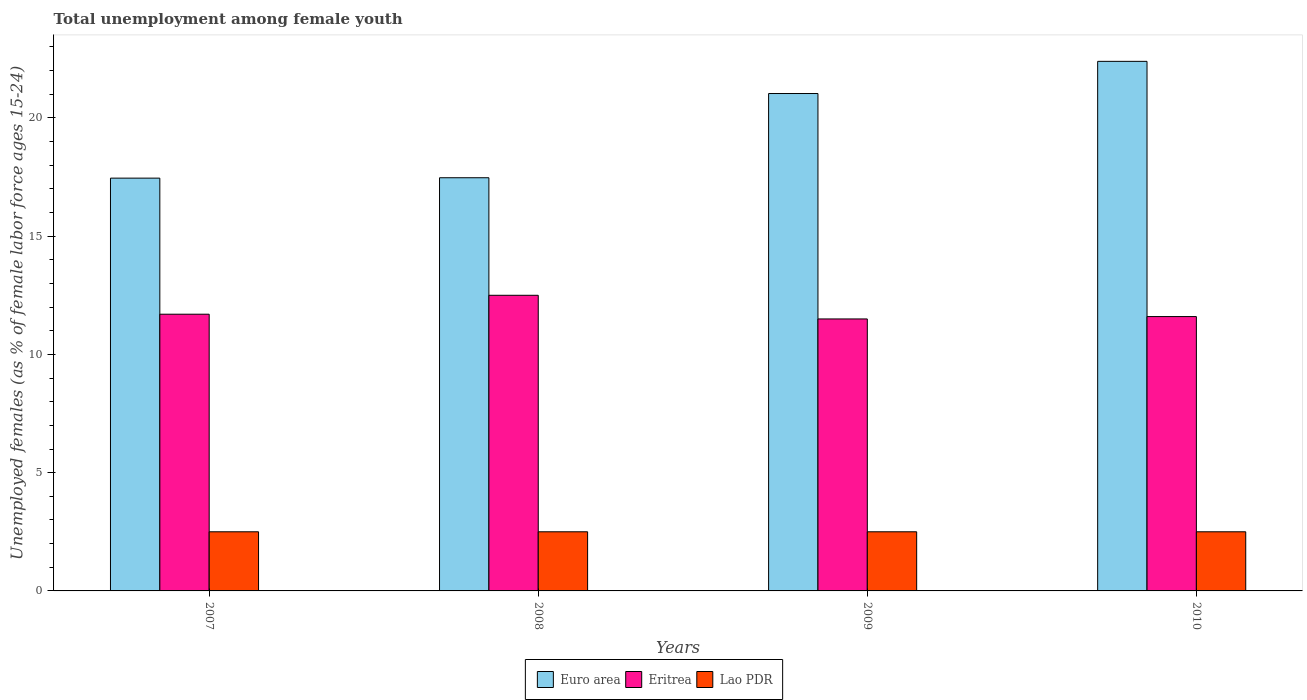How many different coloured bars are there?
Keep it short and to the point. 3. How many groups of bars are there?
Ensure brevity in your answer.  4. How many bars are there on the 3rd tick from the left?
Your response must be concise. 3. What is the label of the 4th group of bars from the left?
Keep it short and to the point. 2010. In how many cases, is the number of bars for a given year not equal to the number of legend labels?
Ensure brevity in your answer.  0. What is the percentage of unemployed females in in Euro area in 2007?
Give a very brief answer. 17.45. Across all years, what is the maximum percentage of unemployed females in in Euro area?
Provide a succinct answer. 22.39. In which year was the percentage of unemployed females in in Lao PDR minimum?
Your answer should be very brief. 2007. What is the total percentage of unemployed females in in Lao PDR in the graph?
Provide a succinct answer. 10. What is the difference between the percentage of unemployed females in in Euro area in 2007 and that in 2010?
Keep it short and to the point. -4.94. What is the difference between the percentage of unemployed females in in Euro area in 2010 and the percentage of unemployed females in in Eritrea in 2009?
Offer a very short reply. 10.89. In the year 2009, what is the difference between the percentage of unemployed females in in Eritrea and percentage of unemployed females in in Euro area?
Your answer should be very brief. -9.53. In how many years, is the percentage of unemployed females in in Euro area greater than 1 %?
Make the answer very short. 4. Is the difference between the percentage of unemployed females in in Eritrea in 2007 and 2008 greater than the difference between the percentage of unemployed females in in Euro area in 2007 and 2008?
Offer a very short reply. No. What is the difference between the highest and the second highest percentage of unemployed females in in Eritrea?
Your answer should be compact. 0.8. What is the difference between the highest and the lowest percentage of unemployed females in in Lao PDR?
Ensure brevity in your answer.  0. Is the sum of the percentage of unemployed females in in Euro area in 2007 and 2010 greater than the maximum percentage of unemployed females in in Eritrea across all years?
Offer a terse response. Yes. What does the 3rd bar from the left in 2008 represents?
Make the answer very short. Lao PDR. Are all the bars in the graph horizontal?
Provide a short and direct response. No. How many years are there in the graph?
Make the answer very short. 4. What is the difference between two consecutive major ticks on the Y-axis?
Your answer should be compact. 5. Are the values on the major ticks of Y-axis written in scientific E-notation?
Your response must be concise. No. Does the graph contain any zero values?
Your response must be concise. No. Does the graph contain grids?
Your response must be concise. No. Where does the legend appear in the graph?
Keep it short and to the point. Bottom center. How are the legend labels stacked?
Provide a succinct answer. Horizontal. What is the title of the graph?
Offer a terse response. Total unemployment among female youth. Does "Tanzania" appear as one of the legend labels in the graph?
Provide a short and direct response. No. What is the label or title of the X-axis?
Keep it short and to the point. Years. What is the label or title of the Y-axis?
Your answer should be very brief. Unemployed females (as % of female labor force ages 15-24). What is the Unemployed females (as % of female labor force ages 15-24) of Euro area in 2007?
Your answer should be very brief. 17.45. What is the Unemployed females (as % of female labor force ages 15-24) in Eritrea in 2007?
Provide a short and direct response. 11.7. What is the Unemployed females (as % of female labor force ages 15-24) of Euro area in 2008?
Offer a terse response. 17.47. What is the Unemployed females (as % of female labor force ages 15-24) of Eritrea in 2008?
Your answer should be very brief. 12.5. What is the Unemployed females (as % of female labor force ages 15-24) of Euro area in 2009?
Give a very brief answer. 21.03. What is the Unemployed females (as % of female labor force ages 15-24) in Eritrea in 2009?
Make the answer very short. 11.5. What is the Unemployed females (as % of female labor force ages 15-24) of Euro area in 2010?
Keep it short and to the point. 22.39. What is the Unemployed females (as % of female labor force ages 15-24) of Eritrea in 2010?
Offer a very short reply. 11.6. Across all years, what is the maximum Unemployed females (as % of female labor force ages 15-24) in Euro area?
Provide a short and direct response. 22.39. Across all years, what is the maximum Unemployed females (as % of female labor force ages 15-24) in Lao PDR?
Provide a succinct answer. 2.5. Across all years, what is the minimum Unemployed females (as % of female labor force ages 15-24) of Euro area?
Your answer should be very brief. 17.45. Across all years, what is the minimum Unemployed females (as % of female labor force ages 15-24) in Eritrea?
Your answer should be compact. 11.5. What is the total Unemployed females (as % of female labor force ages 15-24) in Euro area in the graph?
Provide a short and direct response. 78.35. What is the total Unemployed females (as % of female labor force ages 15-24) of Eritrea in the graph?
Your answer should be very brief. 47.3. What is the total Unemployed females (as % of female labor force ages 15-24) of Lao PDR in the graph?
Ensure brevity in your answer.  10. What is the difference between the Unemployed females (as % of female labor force ages 15-24) of Euro area in 2007 and that in 2008?
Your answer should be compact. -0.02. What is the difference between the Unemployed females (as % of female labor force ages 15-24) in Eritrea in 2007 and that in 2008?
Your answer should be very brief. -0.8. What is the difference between the Unemployed females (as % of female labor force ages 15-24) in Lao PDR in 2007 and that in 2008?
Make the answer very short. 0. What is the difference between the Unemployed females (as % of female labor force ages 15-24) of Euro area in 2007 and that in 2009?
Your response must be concise. -3.58. What is the difference between the Unemployed females (as % of female labor force ages 15-24) of Euro area in 2007 and that in 2010?
Ensure brevity in your answer.  -4.94. What is the difference between the Unemployed females (as % of female labor force ages 15-24) in Lao PDR in 2007 and that in 2010?
Make the answer very short. 0. What is the difference between the Unemployed females (as % of female labor force ages 15-24) in Euro area in 2008 and that in 2009?
Make the answer very short. -3.56. What is the difference between the Unemployed females (as % of female labor force ages 15-24) of Eritrea in 2008 and that in 2009?
Offer a terse response. 1. What is the difference between the Unemployed females (as % of female labor force ages 15-24) in Lao PDR in 2008 and that in 2009?
Ensure brevity in your answer.  0. What is the difference between the Unemployed females (as % of female labor force ages 15-24) of Euro area in 2008 and that in 2010?
Ensure brevity in your answer.  -4.92. What is the difference between the Unemployed females (as % of female labor force ages 15-24) of Eritrea in 2008 and that in 2010?
Offer a very short reply. 0.9. What is the difference between the Unemployed females (as % of female labor force ages 15-24) in Lao PDR in 2008 and that in 2010?
Offer a terse response. 0. What is the difference between the Unemployed females (as % of female labor force ages 15-24) in Euro area in 2009 and that in 2010?
Make the answer very short. -1.36. What is the difference between the Unemployed females (as % of female labor force ages 15-24) in Euro area in 2007 and the Unemployed females (as % of female labor force ages 15-24) in Eritrea in 2008?
Offer a terse response. 4.95. What is the difference between the Unemployed females (as % of female labor force ages 15-24) of Euro area in 2007 and the Unemployed females (as % of female labor force ages 15-24) of Lao PDR in 2008?
Provide a short and direct response. 14.95. What is the difference between the Unemployed females (as % of female labor force ages 15-24) of Eritrea in 2007 and the Unemployed females (as % of female labor force ages 15-24) of Lao PDR in 2008?
Your answer should be compact. 9.2. What is the difference between the Unemployed females (as % of female labor force ages 15-24) in Euro area in 2007 and the Unemployed females (as % of female labor force ages 15-24) in Eritrea in 2009?
Provide a short and direct response. 5.95. What is the difference between the Unemployed females (as % of female labor force ages 15-24) of Euro area in 2007 and the Unemployed females (as % of female labor force ages 15-24) of Lao PDR in 2009?
Provide a succinct answer. 14.95. What is the difference between the Unemployed females (as % of female labor force ages 15-24) of Eritrea in 2007 and the Unemployed females (as % of female labor force ages 15-24) of Lao PDR in 2009?
Your answer should be compact. 9.2. What is the difference between the Unemployed females (as % of female labor force ages 15-24) in Euro area in 2007 and the Unemployed females (as % of female labor force ages 15-24) in Eritrea in 2010?
Ensure brevity in your answer.  5.85. What is the difference between the Unemployed females (as % of female labor force ages 15-24) of Euro area in 2007 and the Unemployed females (as % of female labor force ages 15-24) of Lao PDR in 2010?
Give a very brief answer. 14.95. What is the difference between the Unemployed females (as % of female labor force ages 15-24) of Euro area in 2008 and the Unemployed females (as % of female labor force ages 15-24) of Eritrea in 2009?
Give a very brief answer. 5.97. What is the difference between the Unemployed females (as % of female labor force ages 15-24) of Euro area in 2008 and the Unemployed females (as % of female labor force ages 15-24) of Lao PDR in 2009?
Your response must be concise. 14.97. What is the difference between the Unemployed females (as % of female labor force ages 15-24) in Euro area in 2008 and the Unemployed females (as % of female labor force ages 15-24) in Eritrea in 2010?
Your answer should be compact. 5.87. What is the difference between the Unemployed females (as % of female labor force ages 15-24) in Euro area in 2008 and the Unemployed females (as % of female labor force ages 15-24) in Lao PDR in 2010?
Keep it short and to the point. 14.97. What is the difference between the Unemployed females (as % of female labor force ages 15-24) in Eritrea in 2008 and the Unemployed females (as % of female labor force ages 15-24) in Lao PDR in 2010?
Your response must be concise. 10. What is the difference between the Unemployed females (as % of female labor force ages 15-24) in Euro area in 2009 and the Unemployed females (as % of female labor force ages 15-24) in Eritrea in 2010?
Your answer should be very brief. 9.43. What is the difference between the Unemployed females (as % of female labor force ages 15-24) in Euro area in 2009 and the Unemployed females (as % of female labor force ages 15-24) in Lao PDR in 2010?
Your answer should be compact. 18.53. What is the average Unemployed females (as % of female labor force ages 15-24) of Euro area per year?
Provide a succinct answer. 19.59. What is the average Unemployed females (as % of female labor force ages 15-24) in Eritrea per year?
Your response must be concise. 11.82. In the year 2007, what is the difference between the Unemployed females (as % of female labor force ages 15-24) of Euro area and Unemployed females (as % of female labor force ages 15-24) of Eritrea?
Your answer should be compact. 5.75. In the year 2007, what is the difference between the Unemployed females (as % of female labor force ages 15-24) of Euro area and Unemployed females (as % of female labor force ages 15-24) of Lao PDR?
Ensure brevity in your answer.  14.95. In the year 2008, what is the difference between the Unemployed females (as % of female labor force ages 15-24) in Euro area and Unemployed females (as % of female labor force ages 15-24) in Eritrea?
Offer a very short reply. 4.97. In the year 2008, what is the difference between the Unemployed females (as % of female labor force ages 15-24) of Euro area and Unemployed females (as % of female labor force ages 15-24) of Lao PDR?
Keep it short and to the point. 14.97. In the year 2009, what is the difference between the Unemployed females (as % of female labor force ages 15-24) of Euro area and Unemployed females (as % of female labor force ages 15-24) of Eritrea?
Keep it short and to the point. 9.53. In the year 2009, what is the difference between the Unemployed females (as % of female labor force ages 15-24) of Euro area and Unemployed females (as % of female labor force ages 15-24) of Lao PDR?
Make the answer very short. 18.53. In the year 2009, what is the difference between the Unemployed females (as % of female labor force ages 15-24) in Eritrea and Unemployed females (as % of female labor force ages 15-24) in Lao PDR?
Your response must be concise. 9. In the year 2010, what is the difference between the Unemployed females (as % of female labor force ages 15-24) in Euro area and Unemployed females (as % of female labor force ages 15-24) in Eritrea?
Keep it short and to the point. 10.79. In the year 2010, what is the difference between the Unemployed females (as % of female labor force ages 15-24) of Euro area and Unemployed females (as % of female labor force ages 15-24) of Lao PDR?
Make the answer very short. 19.89. In the year 2010, what is the difference between the Unemployed females (as % of female labor force ages 15-24) in Eritrea and Unemployed females (as % of female labor force ages 15-24) in Lao PDR?
Your response must be concise. 9.1. What is the ratio of the Unemployed females (as % of female labor force ages 15-24) in Euro area in 2007 to that in 2008?
Your answer should be compact. 1. What is the ratio of the Unemployed females (as % of female labor force ages 15-24) of Eritrea in 2007 to that in 2008?
Your answer should be very brief. 0.94. What is the ratio of the Unemployed females (as % of female labor force ages 15-24) of Euro area in 2007 to that in 2009?
Your response must be concise. 0.83. What is the ratio of the Unemployed females (as % of female labor force ages 15-24) in Eritrea in 2007 to that in 2009?
Give a very brief answer. 1.02. What is the ratio of the Unemployed females (as % of female labor force ages 15-24) of Euro area in 2007 to that in 2010?
Your response must be concise. 0.78. What is the ratio of the Unemployed females (as % of female labor force ages 15-24) in Eritrea in 2007 to that in 2010?
Offer a very short reply. 1.01. What is the ratio of the Unemployed females (as % of female labor force ages 15-24) of Euro area in 2008 to that in 2009?
Provide a short and direct response. 0.83. What is the ratio of the Unemployed females (as % of female labor force ages 15-24) in Eritrea in 2008 to that in 2009?
Offer a very short reply. 1.09. What is the ratio of the Unemployed females (as % of female labor force ages 15-24) of Lao PDR in 2008 to that in 2009?
Offer a terse response. 1. What is the ratio of the Unemployed females (as % of female labor force ages 15-24) of Euro area in 2008 to that in 2010?
Make the answer very short. 0.78. What is the ratio of the Unemployed females (as % of female labor force ages 15-24) of Eritrea in 2008 to that in 2010?
Keep it short and to the point. 1.08. What is the ratio of the Unemployed females (as % of female labor force ages 15-24) in Lao PDR in 2008 to that in 2010?
Ensure brevity in your answer.  1. What is the ratio of the Unemployed females (as % of female labor force ages 15-24) of Euro area in 2009 to that in 2010?
Make the answer very short. 0.94. What is the ratio of the Unemployed females (as % of female labor force ages 15-24) in Eritrea in 2009 to that in 2010?
Your response must be concise. 0.99. What is the ratio of the Unemployed females (as % of female labor force ages 15-24) of Lao PDR in 2009 to that in 2010?
Ensure brevity in your answer.  1. What is the difference between the highest and the second highest Unemployed females (as % of female labor force ages 15-24) in Euro area?
Ensure brevity in your answer.  1.36. What is the difference between the highest and the lowest Unemployed females (as % of female labor force ages 15-24) in Euro area?
Your answer should be very brief. 4.94. 